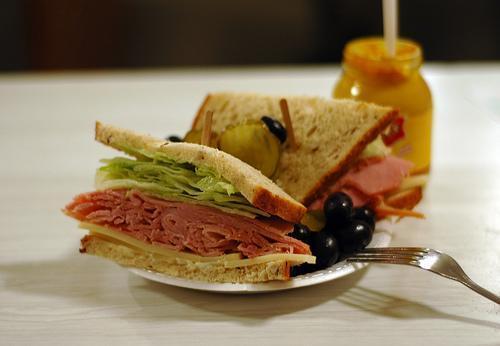How many forks displayed in photo?
Give a very brief answer. 1. 